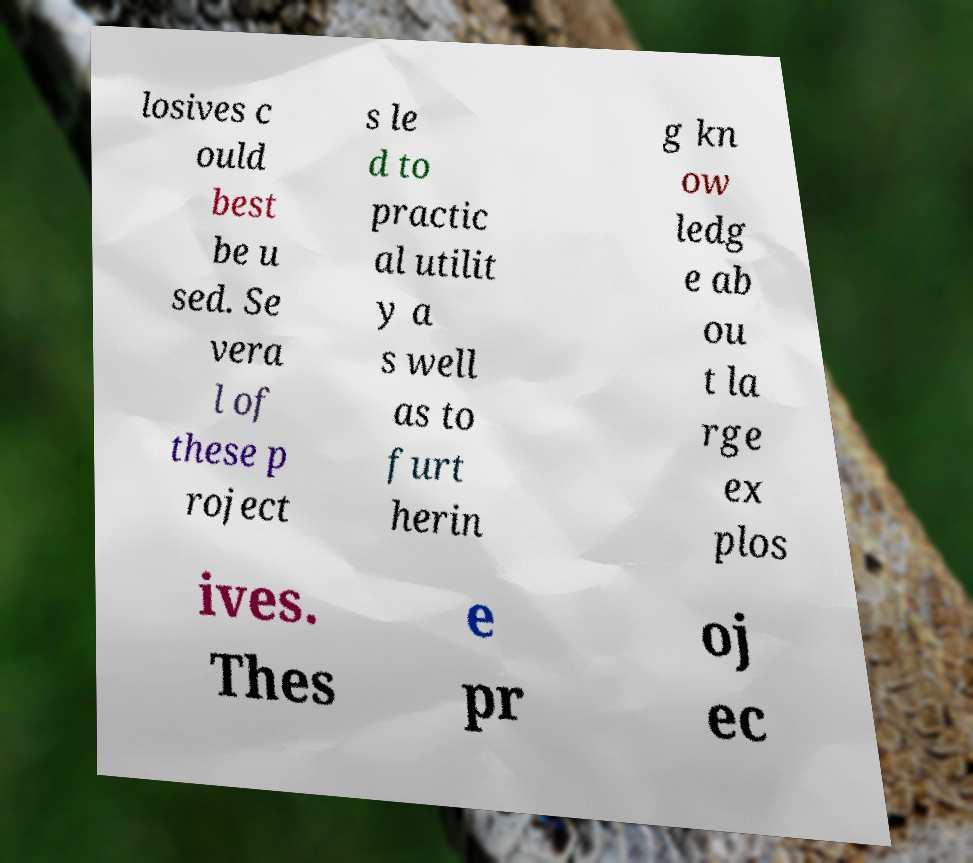Can you read and provide the text displayed in the image?This photo seems to have some interesting text. Can you extract and type it out for me? losives c ould best be u sed. Se vera l of these p roject s le d to practic al utilit y a s well as to furt herin g kn ow ledg e ab ou t la rge ex plos ives. Thes e pr oj ec 